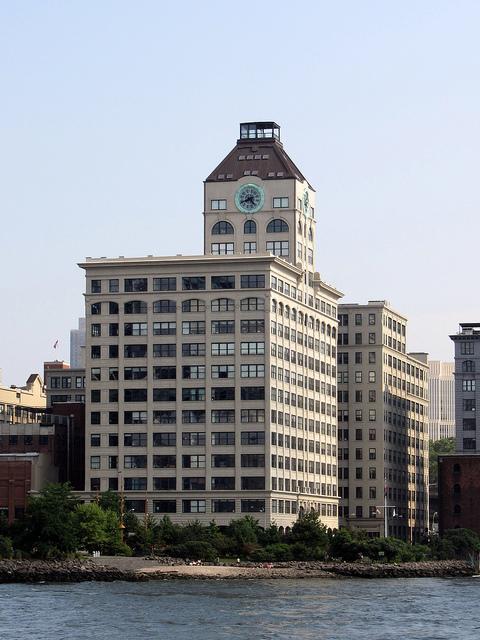How many boats on the water?
Give a very brief answer. 0. 